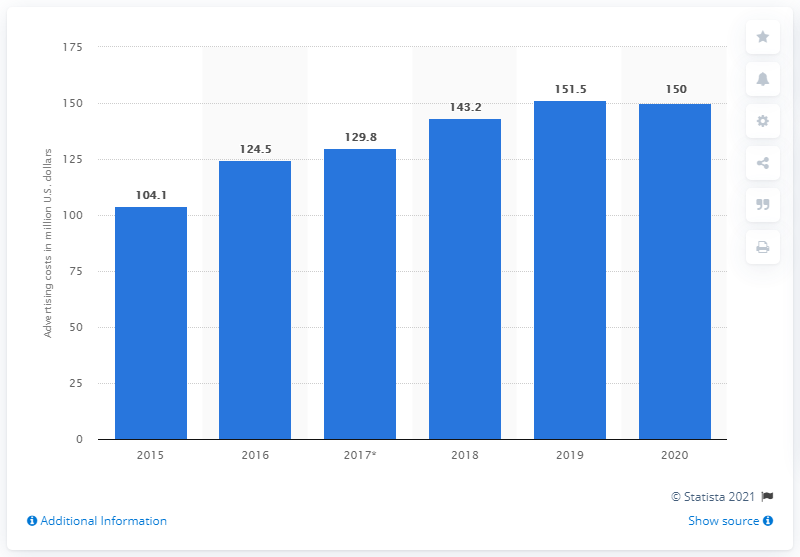Specify some key components in this picture. The global advertising expenses of American Eagle Outfitters amounted to $150 million in 2020. 